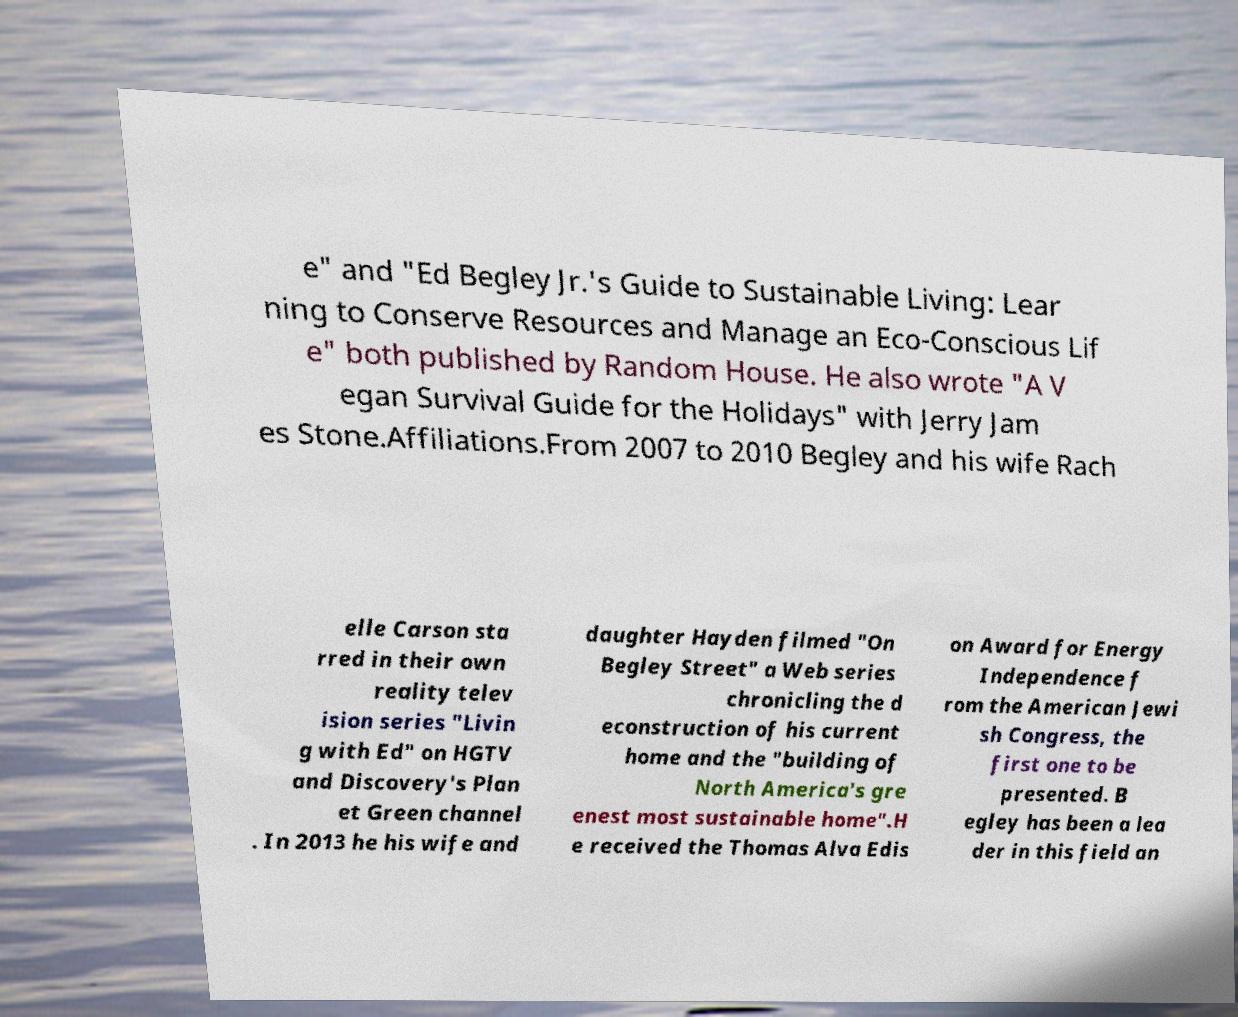I need the written content from this picture converted into text. Can you do that? e" and "Ed Begley Jr.'s Guide to Sustainable Living: Lear ning to Conserve Resources and Manage an Eco-Conscious Lif e" both published by Random House. He also wrote "A V egan Survival Guide for the Holidays" with Jerry Jam es Stone.Affiliations.From 2007 to 2010 Begley and his wife Rach elle Carson sta rred in their own reality telev ision series "Livin g with Ed" on HGTV and Discovery's Plan et Green channel . In 2013 he his wife and daughter Hayden filmed "On Begley Street" a Web series chronicling the d econstruction of his current home and the "building of North America's gre enest most sustainable home".H e received the Thomas Alva Edis on Award for Energy Independence f rom the American Jewi sh Congress, the first one to be presented. B egley has been a lea der in this field an 